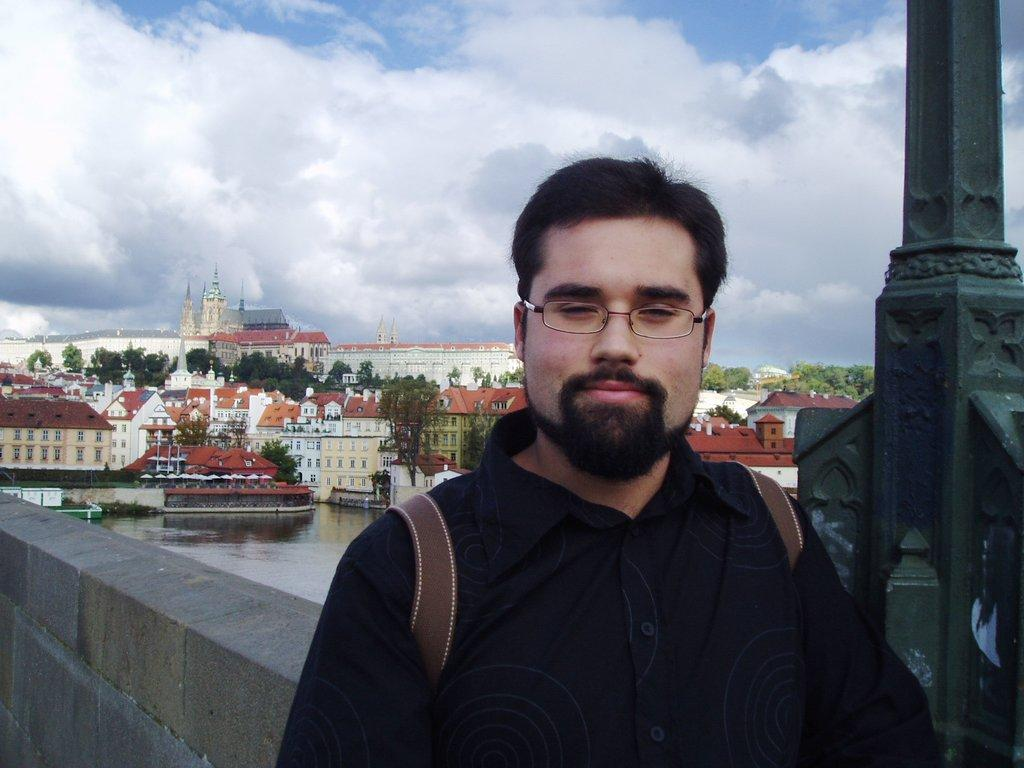What is the main subject of the image? There is a man standing in the image. Where is the man standing? The man is standing on the floor. What can be seen in the background of the image? There is sky, clouds, buildings, trees, poles, and water visible in the background of the image. What type of scent can be detected coming from the man in the image? There is no information about the scent of the man in the image, so it cannot be determined. 